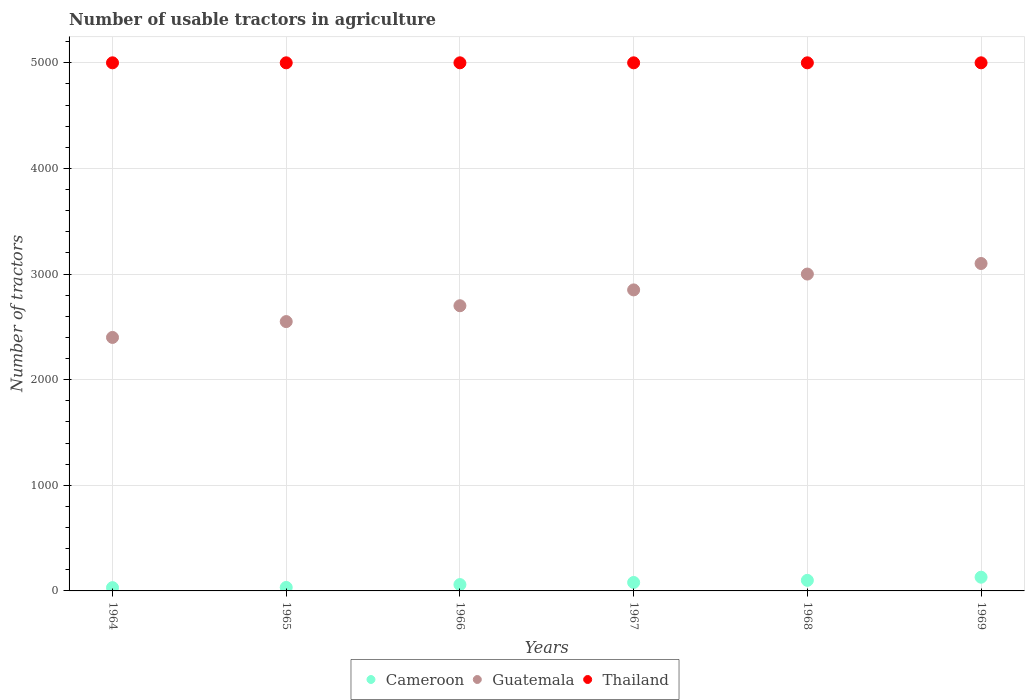How many different coloured dotlines are there?
Your answer should be very brief. 3. Is the number of dotlines equal to the number of legend labels?
Give a very brief answer. Yes. Across all years, what is the maximum number of usable tractors in agriculture in Thailand?
Make the answer very short. 5000. In which year was the number of usable tractors in agriculture in Thailand maximum?
Ensure brevity in your answer.  1964. In which year was the number of usable tractors in agriculture in Guatemala minimum?
Your answer should be compact. 1964. What is the total number of usable tractors in agriculture in Cameroon in the graph?
Your response must be concise. 434. What is the difference between the number of usable tractors in agriculture in Cameroon in 1964 and that in 1967?
Provide a short and direct response. -49. What is the difference between the number of usable tractors in agriculture in Thailand in 1969 and the number of usable tractors in agriculture in Guatemala in 1968?
Your answer should be compact. 2000. What is the average number of usable tractors in agriculture in Cameroon per year?
Provide a short and direct response. 72.33. In the year 1966, what is the difference between the number of usable tractors in agriculture in Cameroon and number of usable tractors in agriculture in Thailand?
Your answer should be compact. -4940. In how many years, is the number of usable tractors in agriculture in Thailand greater than 4400?
Your answer should be compact. 6. What is the ratio of the number of usable tractors in agriculture in Guatemala in 1964 to that in 1968?
Your answer should be compact. 0.8. Is the number of usable tractors in agriculture in Guatemala in 1964 less than that in 1969?
Give a very brief answer. Yes. What is the difference between the highest and the second highest number of usable tractors in agriculture in Guatemala?
Ensure brevity in your answer.  100. What is the difference between the highest and the lowest number of usable tractors in agriculture in Thailand?
Offer a terse response. 0. Is the sum of the number of usable tractors in agriculture in Thailand in 1965 and 1969 greater than the maximum number of usable tractors in agriculture in Guatemala across all years?
Keep it short and to the point. Yes. Is the number of usable tractors in agriculture in Cameroon strictly greater than the number of usable tractors in agriculture in Guatemala over the years?
Keep it short and to the point. No. How many years are there in the graph?
Offer a terse response. 6. What is the difference between two consecutive major ticks on the Y-axis?
Ensure brevity in your answer.  1000. Are the values on the major ticks of Y-axis written in scientific E-notation?
Provide a short and direct response. No. Does the graph contain any zero values?
Ensure brevity in your answer.  No. What is the title of the graph?
Offer a very short reply. Number of usable tractors in agriculture. Does "Puerto Rico" appear as one of the legend labels in the graph?
Provide a short and direct response. No. What is the label or title of the X-axis?
Offer a terse response. Years. What is the label or title of the Y-axis?
Make the answer very short. Number of tractors. What is the Number of tractors of Guatemala in 1964?
Your answer should be compact. 2400. What is the Number of tractors in Cameroon in 1965?
Provide a succinct answer. 33. What is the Number of tractors of Guatemala in 1965?
Your answer should be very brief. 2550. What is the Number of tractors in Thailand in 1965?
Make the answer very short. 5000. What is the Number of tractors of Guatemala in 1966?
Ensure brevity in your answer.  2700. What is the Number of tractors in Thailand in 1966?
Offer a very short reply. 5000. What is the Number of tractors in Guatemala in 1967?
Provide a short and direct response. 2850. What is the Number of tractors of Thailand in 1967?
Give a very brief answer. 5000. What is the Number of tractors of Guatemala in 1968?
Give a very brief answer. 3000. What is the Number of tractors of Cameroon in 1969?
Your answer should be compact. 130. What is the Number of tractors of Guatemala in 1969?
Offer a terse response. 3100. Across all years, what is the maximum Number of tractors of Cameroon?
Ensure brevity in your answer.  130. Across all years, what is the maximum Number of tractors of Guatemala?
Offer a terse response. 3100. Across all years, what is the maximum Number of tractors of Thailand?
Offer a terse response. 5000. Across all years, what is the minimum Number of tractors in Guatemala?
Make the answer very short. 2400. Across all years, what is the minimum Number of tractors of Thailand?
Keep it short and to the point. 5000. What is the total Number of tractors in Cameroon in the graph?
Give a very brief answer. 434. What is the total Number of tractors in Guatemala in the graph?
Ensure brevity in your answer.  1.66e+04. What is the total Number of tractors in Thailand in the graph?
Give a very brief answer. 3.00e+04. What is the difference between the Number of tractors of Cameroon in 1964 and that in 1965?
Your response must be concise. -2. What is the difference between the Number of tractors of Guatemala in 1964 and that in 1965?
Provide a succinct answer. -150. What is the difference between the Number of tractors of Guatemala in 1964 and that in 1966?
Provide a short and direct response. -300. What is the difference between the Number of tractors in Cameroon in 1964 and that in 1967?
Provide a succinct answer. -49. What is the difference between the Number of tractors of Guatemala in 1964 and that in 1967?
Your answer should be very brief. -450. What is the difference between the Number of tractors in Thailand in 1964 and that in 1967?
Provide a short and direct response. 0. What is the difference between the Number of tractors in Cameroon in 1964 and that in 1968?
Offer a very short reply. -69. What is the difference between the Number of tractors of Guatemala in 1964 and that in 1968?
Provide a succinct answer. -600. What is the difference between the Number of tractors of Thailand in 1964 and that in 1968?
Give a very brief answer. 0. What is the difference between the Number of tractors of Cameroon in 1964 and that in 1969?
Make the answer very short. -99. What is the difference between the Number of tractors of Guatemala in 1964 and that in 1969?
Your answer should be very brief. -700. What is the difference between the Number of tractors in Cameroon in 1965 and that in 1966?
Make the answer very short. -27. What is the difference between the Number of tractors of Guatemala in 1965 and that in 1966?
Ensure brevity in your answer.  -150. What is the difference between the Number of tractors of Thailand in 1965 and that in 1966?
Your response must be concise. 0. What is the difference between the Number of tractors in Cameroon in 1965 and that in 1967?
Offer a terse response. -47. What is the difference between the Number of tractors in Guatemala in 1965 and that in 1967?
Your answer should be compact. -300. What is the difference between the Number of tractors of Thailand in 1965 and that in 1967?
Provide a short and direct response. 0. What is the difference between the Number of tractors of Cameroon in 1965 and that in 1968?
Give a very brief answer. -67. What is the difference between the Number of tractors of Guatemala in 1965 and that in 1968?
Your response must be concise. -450. What is the difference between the Number of tractors in Cameroon in 1965 and that in 1969?
Provide a succinct answer. -97. What is the difference between the Number of tractors in Guatemala in 1965 and that in 1969?
Offer a terse response. -550. What is the difference between the Number of tractors in Cameroon in 1966 and that in 1967?
Your answer should be compact. -20. What is the difference between the Number of tractors of Guatemala in 1966 and that in 1967?
Make the answer very short. -150. What is the difference between the Number of tractors of Thailand in 1966 and that in 1967?
Ensure brevity in your answer.  0. What is the difference between the Number of tractors of Cameroon in 1966 and that in 1968?
Keep it short and to the point. -40. What is the difference between the Number of tractors in Guatemala in 1966 and that in 1968?
Provide a succinct answer. -300. What is the difference between the Number of tractors in Cameroon in 1966 and that in 1969?
Keep it short and to the point. -70. What is the difference between the Number of tractors of Guatemala in 1966 and that in 1969?
Provide a succinct answer. -400. What is the difference between the Number of tractors of Guatemala in 1967 and that in 1968?
Your answer should be very brief. -150. What is the difference between the Number of tractors of Thailand in 1967 and that in 1968?
Your response must be concise. 0. What is the difference between the Number of tractors in Cameroon in 1967 and that in 1969?
Ensure brevity in your answer.  -50. What is the difference between the Number of tractors in Guatemala in 1967 and that in 1969?
Your answer should be compact. -250. What is the difference between the Number of tractors of Thailand in 1967 and that in 1969?
Give a very brief answer. 0. What is the difference between the Number of tractors in Guatemala in 1968 and that in 1969?
Make the answer very short. -100. What is the difference between the Number of tractors in Cameroon in 1964 and the Number of tractors in Guatemala in 1965?
Keep it short and to the point. -2519. What is the difference between the Number of tractors of Cameroon in 1964 and the Number of tractors of Thailand in 1965?
Provide a short and direct response. -4969. What is the difference between the Number of tractors in Guatemala in 1964 and the Number of tractors in Thailand in 1965?
Your answer should be very brief. -2600. What is the difference between the Number of tractors of Cameroon in 1964 and the Number of tractors of Guatemala in 1966?
Your answer should be very brief. -2669. What is the difference between the Number of tractors in Cameroon in 1964 and the Number of tractors in Thailand in 1966?
Your response must be concise. -4969. What is the difference between the Number of tractors in Guatemala in 1964 and the Number of tractors in Thailand in 1966?
Ensure brevity in your answer.  -2600. What is the difference between the Number of tractors in Cameroon in 1964 and the Number of tractors in Guatemala in 1967?
Ensure brevity in your answer.  -2819. What is the difference between the Number of tractors of Cameroon in 1964 and the Number of tractors of Thailand in 1967?
Your response must be concise. -4969. What is the difference between the Number of tractors of Guatemala in 1964 and the Number of tractors of Thailand in 1967?
Provide a short and direct response. -2600. What is the difference between the Number of tractors in Cameroon in 1964 and the Number of tractors in Guatemala in 1968?
Offer a very short reply. -2969. What is the difference between the Number of tractors of Cameroon in 1964 and the Number of tractors of Thailand in 1968?
Give a very brief answer. -4969. What is the difference between the Number of tractors in Guatemala in 1964 and the Number of tractors in Thailand in 1968?
Ensure brevity in your answer.  -2600. What is the difference between the Number of tractors of Cameroon in 1964 and the Number of tractors of Guatemala in 1969?
Ensure brevity in your answer.  -3069. What is the difference between the Number of tractors in Cameroon in 1964 and the Number of tractors in Thailand in 1969?
Make the answer very short. -4969. What is the difference between the Number of tractors in Guatemala in 1964 and the Number of tractors in Thailand in 1969?
Offer a terse response. -2600. What is the difference between the Number of tractors in Cameroon in 1965 and the Number of tractors in Guatemala in 1966?
Keep it short and to the point. -2667. What is the difference between the Number of tractors of Cameroon in 1965 and the Number of tractors of Thailand in 1966?
Offer a terse response. -4967. What is the difference between the Number of tractors in Guatemala in 1965 and the Number of tractors in Thailand in 1966?
Your answer should be very brief. -2450. What is the difference between the Number of tractors of Cameroon in 1965 and the Number of tractors of Guatemala in 1967?
Offer a terse response. -2817. What is the difference between the Number of tractors in Cameroon in 1965 and the Number of tractors in Thailand in 1967?
Provide a succinct answer. -4967. What is the difference between the Number of tractors of Guatemala in 1965 and the Number of tractors of Thailand in 1967?
Offer a very short reply. -2450. What is the difference between the Number of tractors of Cameroon in 1965 and the Number of tractors of Guatemala in 1968?
Your answer should be compact. -2967. What is the difference between the Number of tractors of Cameroon in 1965 and the Number of tractors of Thailand in 1968?
Make the answer very short. -4967. What is the difference between the Number of tractors of Guatemala in 1965 and the Number of tractors of Thailand in 1968?
Your answer should be very brief. -2450. What is the difference between the Number of tractors in Cameroon in 1965 and the Number of tractors in Guatemala in 1969?
Offer a very short reply. -3067. What is the difference between the Number of tractors in Cameroon in 1965 and the Number of tractors in Thailand in 1969?
Provide a succinct answer. -4967. What is the difference between the Number of tractors in Guatemala in 1965 and the Number of tractors in Thailand in 1969?
Give a very brief answer. -2450. What is the difference between the Number of tractors of Cameroon in 1966 and the Number of tractors of Guatemala in 1967?
Your response must be concise. -2790. What is the difference between the Number of tractors in Cameroon in 1966 and the Number of tractors in Thailand in 1967?
Give a very brief answer. -4940. What is the difference between the Number of tractors in Guatemala in 1966 and the Number of tractors in Thailand in 1967?
Provide a short and direct response. -2300. What is the difference between the Number of tractors in Cameroon in 1966 and the Number of tractors in Guatemala in 1968?
Offer a terse response. -2940. What is the difference between the Number of tractors in Cameroon in 1966 and the Number of tractors in Thailand in 1968?
Provide a short and direct response. -4940. What is the difference between the Number of tractors in Guatemala in 1966 and the Number of tractors in Thailand in 1968?
Make the answer very short. -2300. What is the difference between the Number of tractors of Cameroon in 1966 and the Number of tractors of Guatemala in 1969?
Offer a terse response. -3040. What is the difference between the Number of tractors of Cameroon in 1966 and the Number of tractors of Thailand in 1969?
Your answer should be very brief. -4940. What is the difference between the Number of tractors of Guatemala in 1966 and the Number of tractors of Thailand in 1969?
Offer a terse response. -2300. What is the difference between the Number of tractors of Cameroon in 1967 and the Number of tractors of Guatemala in 1968?
Give a very brief answer. -2920. What is the difference between the Number of tractors of Cameroon in 1967 and the Number of tractors of Thailand in 1968?
Provide a short and direct response. -4920. What is the difference between the Number of tractors in Guatemala in 1967 and the Number of tractors in Thailand in 1968?
Provide a succinct answer. -2150. What is the difference between the Number of tractors of Cameroon in 1967 and the Number of tractors of Guatemala in 1969?
Your response must be concise. -3020. What is the difference between the Number of tractors of Cameroon in 1967 and the Number of tractors of Thailand in 1969?
Your answer should be very brief. -4920. What is the difference between the Number of tractors of Guatemala in 1967 and the Number of tractors of Thailand in 1969?
Ensure brevity in your answer.  -2150. What is the difference between the Number of tractors in Cameroon in 1968 and the Number of tractors in Guatemala in 1969?
Keep it short and to the point. -3000. What is the difference between the Number of tractors in Cameroon in 1968 and the Number of tractors in Thailand in 1969?
Provide a succinct answer. -4900. What is the difference between the Number of tractors in Guatemala in 1968 and the Number of tractors in Thailand in 1969?
Offer a very short reply. -2000. What is the average Number of tractors of Cameroon per year?
Offer a very short reply. 72.33. What is the average Number of tractors of Guatemala per year?
Provide a succinct answer. 2766.67. In the year 1964, what is the difference between the Number of tractors of Cameroon and Number of tractors of Guatemala?
Offer a terse response. -2369. In the year 1964, what is the difference between the Number of tractors in Cameroon and Number of tractors in Thailand?
Make the answer very short. -4969. In the year 1964, what is the difference between the Number of tractors of Guatemala and Number of tractors of Thailand?
Provide a succinct answer. -2600. In the year 1965, what is the difference between the Number of tractors of Cameroon and Number of tractors of Guatemala?
Give a very brief answer. -2517. In the year 1965, what is the difference between the Number of tractors of Cameroon and Number of tractors of Thailand?
Ensure brevity in your answer.  -4967. In the year 1965, what is the difference between the Number of tractors of Guatemala and Number of tractors of Thailand?
Provide a succinct answer. -2450. In the year 1966, what is the difference between the Number of tractors in Cameroon and Number of tractors in Guatemala?
Offer a terse response. -2640. In the year 1966, what is the difference between the Number of tractors of Cameroon and Number of tractors of Thailand?
Offer a terse response. -4940. In the year 1966, what is the difference between the Number of tractors in Guatemala and Number of tractors in Thailand?
Give a very brief answer. -2300. In the year 1967, what is the difference between the Number of tractors in Cameroon and Number of tractors in Guatemala?
Provide a short and direct response. -2770. In the year 1967, what is the difference between the Number of tractors of Cameroon and Number of tractors of Thailand?
Make the answer very short. -4920. In the year 1967, what is the difference between the Number of tractors in Guatemala and Number of tractors in Thailand?
Keep it short and to the point. -2150. In the year 1968, what is the difference between the Number of tractors in Cameroon and Number of tractors in Guatemala?
Offer a terse response. -2900. In the year 1968, what is the difference between the Number of tractors in Cameroon and Number of tractors in Thailand?
Offer a very short reply. -4900. In the year 1968, what is the difference between the Number of tractors in Guatemala and Number of tractors in Thailand?
Your response must be concise. -2000. In the year 1969, what is the difference between the Number of tractors of Cameroon and Number of tractors of Guatemala?
Keep it short and to the point. -2970. In the year 1969, what is the difference between the Number of tractors of Cameroon and Number of tractors of Thailand?
Your answer should be very brief. -4870. In the year 1969, what is the difference between the Number of tractors in Guatemala and Number of tractors in Thailand?
Ensure brevity in your answer.  -1900. What is the ratio of the Number of tractors of Cameroon in 1964 to that in 1965?
Your answer should be compact. 0.94. What is the ratio of the Number of tractors of Thailand in 1964 to that in 1965?
Make the answer very short. 1. What is the ratio of the Number of tractors in Cameroon in 1964 to that in 1966?
Provide a succinct answer. 0.52. What is the ratio of the Number of tractors of Guatemala in 1964 to that in 1966?
Offer a very short reply. 0.89. What is the ratio of the Number of tractors in Cameroon in 1964 to that in 1967?
Your answer should be very brief. 0.39. What is the ratio of the Number of tractors of Guatemala in 1964 to that in 1967?
Offer a terse response. 0.84. What is the ratio of the Number of tractors of Cameroon in 1964 to that in 1968?
Offer a very short reply. 0.31. What is the ratio of the Number of tractors of Guatemala in 1964 to that in 1968?
Keep it short and to the point. 0.8. What is the ratio of the Number of tractors in Cameroon in 1964 to that in 1969?
Your response must be concise. 0.24. What is the ratio of the Number of tractors of Guatemala in 1964 to that in 1969?
Provide a succinct answer. 0.77. What is the ratio of the Number of tractors in Cameroon in 1965 to that in 1966?
Ensure brevity in your answer.  0.55. What is the ratio of the Number of tractors in Guatemala in 1965 to that in 1966?
Make the answer very short. 0.94. What is the ratio of the Number of tractors of Cameroon in 1965 to that in 1967?
Ensure brevity in your answer.  0.41. What is the ratio of the Number of tractors in Guatemala in 1965 to that in 1967?
Provide a short and direct response. 0.89. What is the ratio of the Number of tractors of Thailand in 1965 to that in 1967?
Provide a short and direct response. 1. What is the ratio of the Number of tractors of Cameroon in 1965 to that in 1968?
Provide a succinct answer. 0.33. What is the ratio of the Number of tractors in Thailand in 1965 to that in 1968?
Make the answer very short. 1. What is the ratio of the Number of tractors in Cameroon in 1965 to that in 1969?
Your answer should be very brief. 0.25. What is the ratio of the Number of tractors in Guatemala in 1965 to that in 1969?
Your answer should be very brief. 0.82. What is the ratio of the Number of tractors of Thailand in 1965 to that in 1969?
Offer a very short reply. 1. What is the ratio of the Number of tractors of Cameroon in 1966 to that in 1967?
Your answer should be very brief. 0.75. What is the ratio of the Number of tractors of Guatemala in 1966 to that in 1968?
Provide a succinct answer. 0.9. What is the ratio of the Number of tractors of Thailand in 1966 to that in 1968?
Keep it short and to the point. 1. What is the ratio of the Number of tractors in Cameroon in 1966 to that in 1969?
Provide a succinct answer. 0.46. What is the ratio of the Number of tractors in Guatemala in 1966 to that in 1969?
Your answer should be very brief. 0.87. What is the ratio of the Number of tractors of Thailand in 1966 to that in 1969?
Give a very brief answer. 1. What is the ratio of the Number of tractors in Cameroon in 1967 to that in 1968?
Your answer should be compact. 0.8. What is the ratio of the Number of tractors in Guatemala in 1967 to that in 1968?
Give a very brief answer. 0.95. What is the ratio of the Number of tractors of Thailand in 1967 to that in 1968?
Offer a terse response. 1. What is the ratio of the Number of tractors in Cameroon in 1967 to that in 1969?
Your answer should be very brief. 0.62. What is the ratio of the Number of tractors of Guatemala in 1967 to that in 1969?
Ensure brevity in your answer.  0.92. What is the ratio of the Number of tractors in Cameroon in 1968 to that in 1969?
Your answer should be compact. 0.77. What is the ratio of the Number of tractors of Guatemala in 1968 to that in 1969?
Your answer should be very brief. 0.97. What is the difference between the highest and the lowest Number of tractors of Guatemala?
Your response must be concise. 700. 